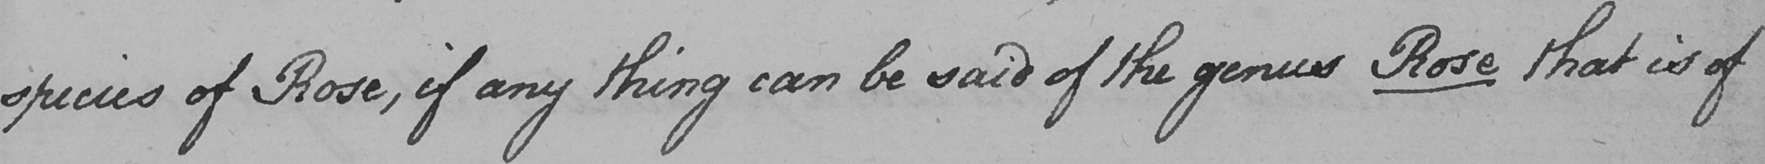What does this handwritten line say? species of Rose , if any thing can be said of the genus Rose that is of 